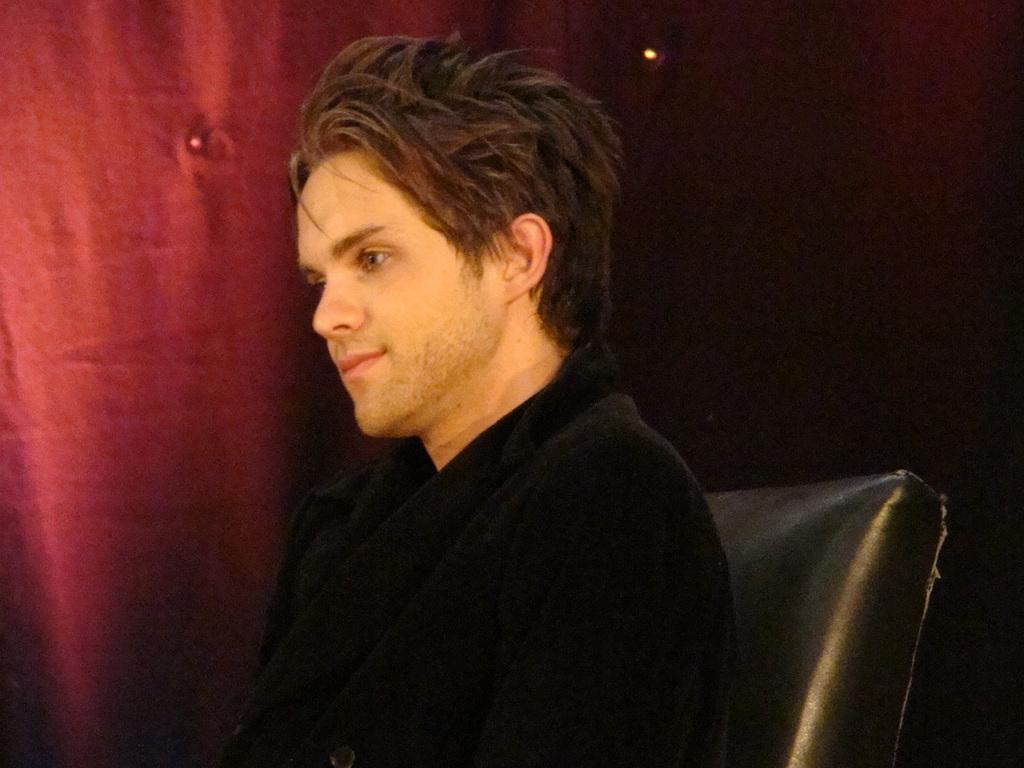What is the person in the image doing? The person is sitting on a chair in the image. What can be seen in the background of the image? There is a red color curtain in the background of the image. What type of ground can be seen beneath the person's feet in the image? There is no ground visible in the image, as the person is sitting on a chair. 